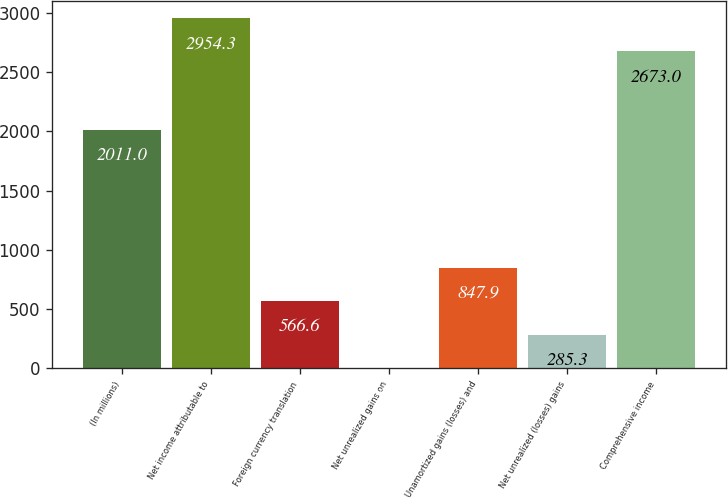Convert chart. <chart><loc_0><loc_0><loc_500><loc_500><bar_chart><fcel>(In millions)<fcel>Net income attributable to<fcel>Foreign currency translation<fcel>Net unrealized gains on<fcel>Unamortized gains (losses) and<fcel>Net unrealized (losses) gains<fcel>Comprehensive income<nl><fcel>2011<fcel>2954.3<fcel>566.6<fcel>4<fcel>847.9<fcel>285.3<fcel>2673<nl></chart> 